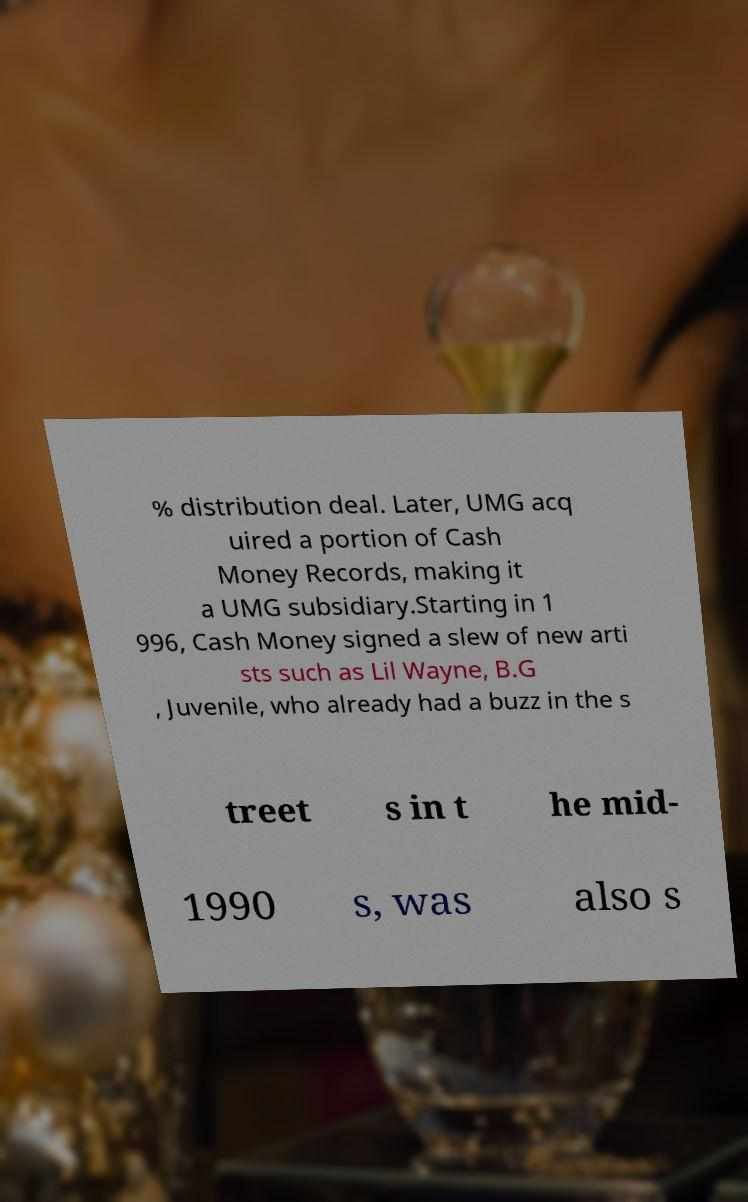I need the written content from this picture converted into text. Can you do that? % distribution deal. Later, UMG acq uired a portion of Cash Money Records, making it a UMG subsidiary.Starting in 1 996, Cash Money signed a slew of new arti sts such as Lil Wayne, B.G , Juvenile, who already had a buzz in the s treet s in t he mid- 1990 s, was also s 